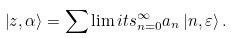<formula> <loc_0><loc_0><loc_500><loc_500>\left | z , \alpha \right \rangle = \sum \lim i t s _ { n = 0 } ^ { \infty } a _ { n } \left | n , \varepsilon \right \rangle .</formula> 